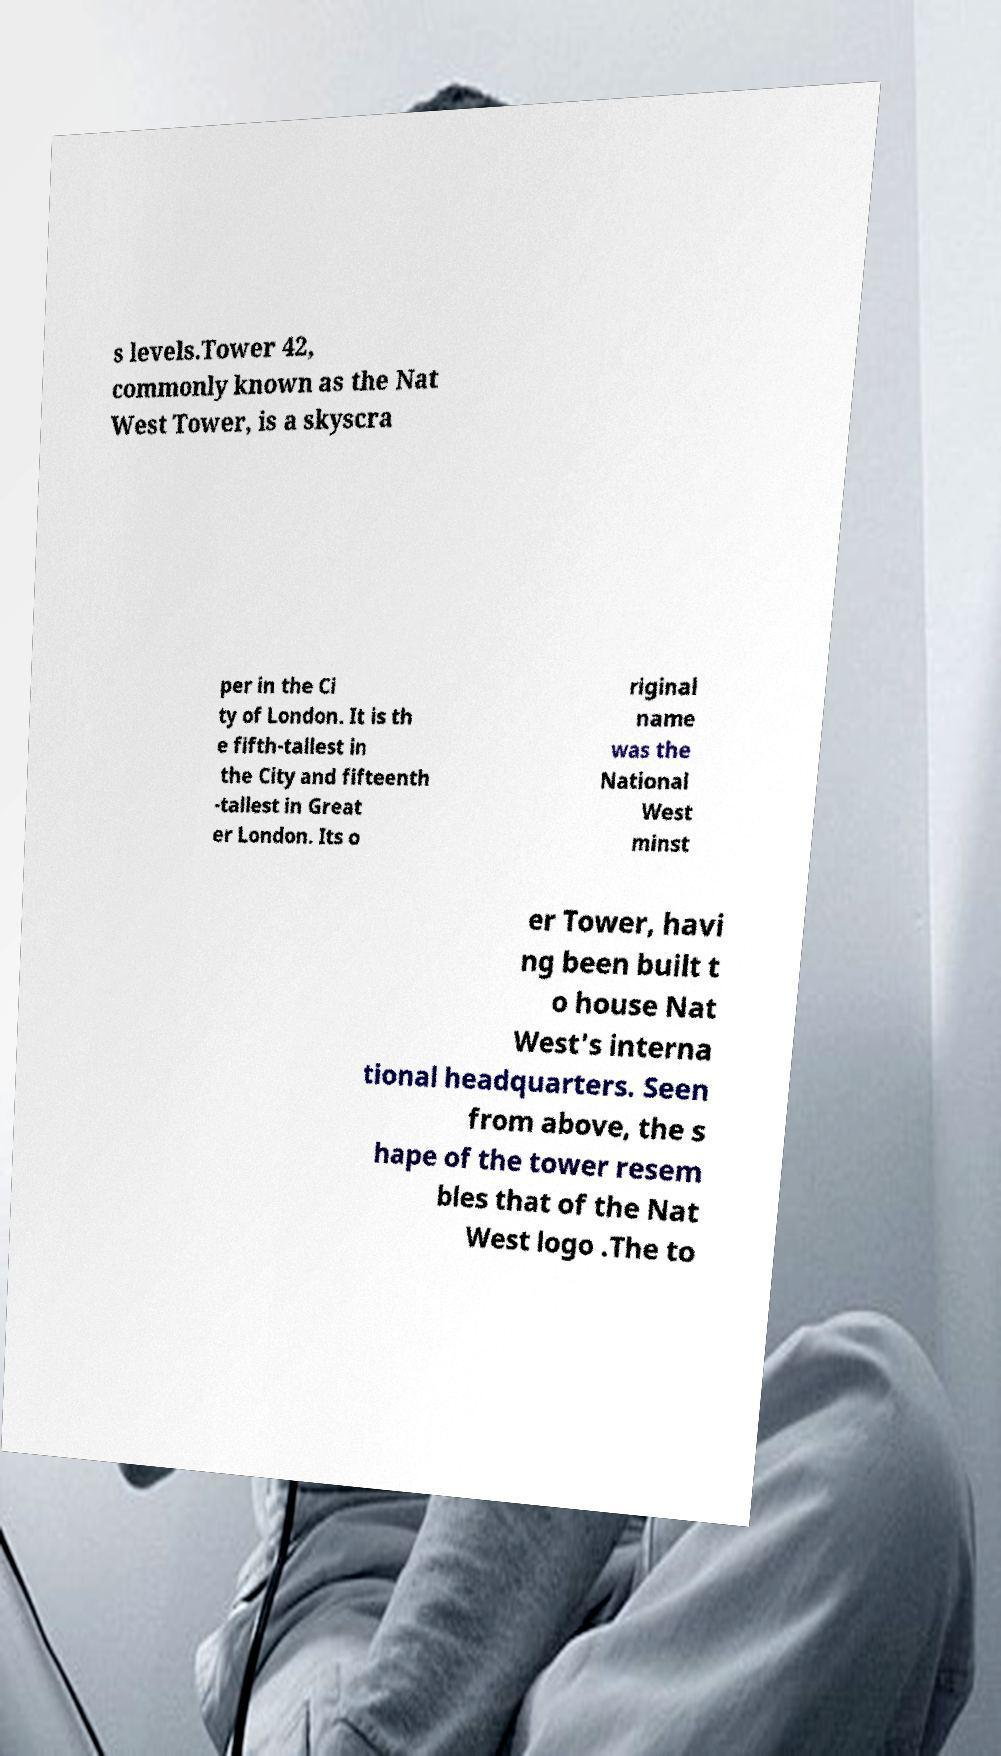There's text embedded in this image that I need extracted. Can you transcribe it verbatim? s levels.Tower 42, commonly known as the Nat West Tower, is a skyscra per in the Ci ty of London. It is th e fifth-tallest in the City and fifteenth -tallest in Great er London. Its o riginal name was the National West minst er Tower, havi ng been built t o house Nat West's interna tional headquarters. Seen from above, the s hape of the tower resem bles that of the Nat West logo .The to 